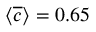Convert formula to latex. <formula><loc_0><loc_0><loc_500><loc_500>\langle \overline { c } \rangle = 0 . 6 5</formula> 